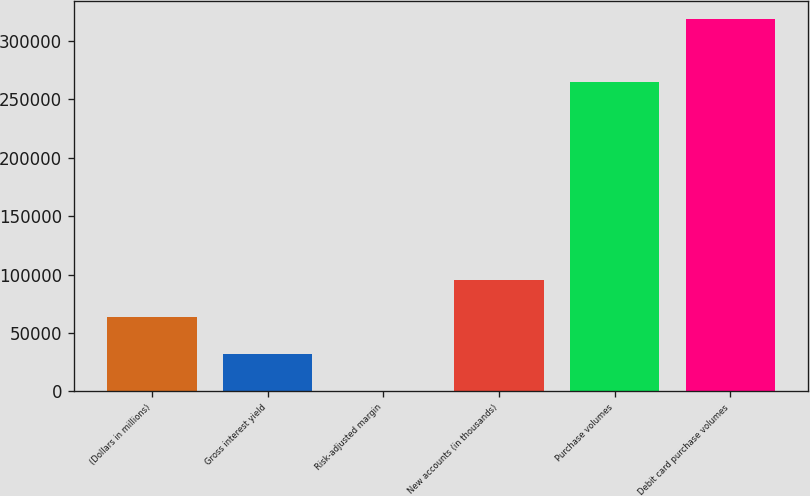Convert chart. <chart><loc_0><loc_0><loc_500><loc_500><bar_chart><fcel>(Dollars in millions)<fcel>Gross interest yield<fcel>Risk-adjusted margin<fcel>New accounts (in thousands)<fcel>Purchase volumes<fcel>Debit card purchase volumes<nl><fcel>63719.1<fcel>31863.7<fcel>8.34<fcel>95574.4<fcel>264706<fcel>318562<nl></chart> 